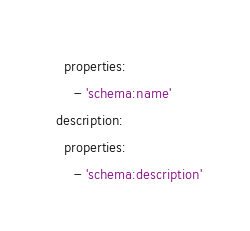Convert code to text. <code><loc_0><loc_0><loc_500><loc_500><_YAML_>    properties:
      - 'schema:name'
  description:
    properties:
      - 'schema:description'
</code> 